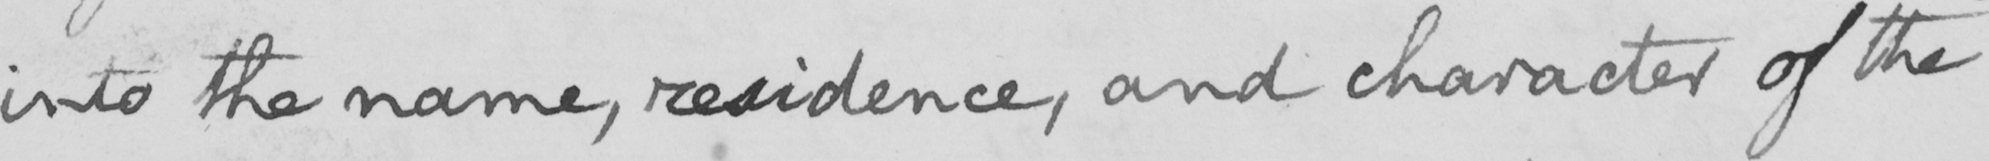Can you tell me what this handwritten text says? into the name , residence , and character of the 